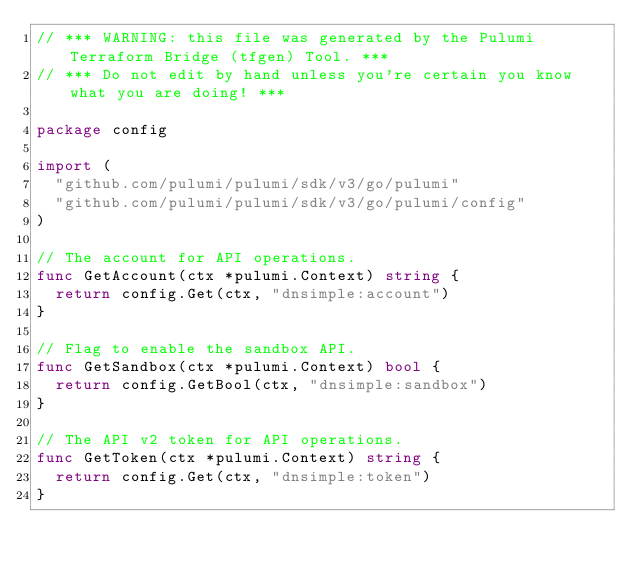Convert code to text. <code><loc_0><loc_0><loc_500><loc_500><_Go_>// *** WARNING: this file was generated by the Pulumi Terraform Bridge (tfgen) Tool. ***
// *** Do not edit by hand unless you're certain you know what you are doing! ***

package config

import (
	"github.com/pulumi/pulumi/sdk/v3/go/pulumi"
	"github.com/pulumi/pulumi/sdk/v3/go/pulumi/config"
)

// The account for API operations.
func GetAccount(ctx *pulumi.Context) string {
	return config.Get(ctx, "dnsimple:account")
}

// Flag to enable the sandbox API.
func GetSandbox(ctx *pulumi.Context) bool {
	return config.GetBool(ctx, "dnsimple:sandbox")
}

// The API v2 token for API operations.
func GetToken(ctx *pulumi.Context) string {
	return config.Get(ctx, "dnsimple:token")
}
</code> 